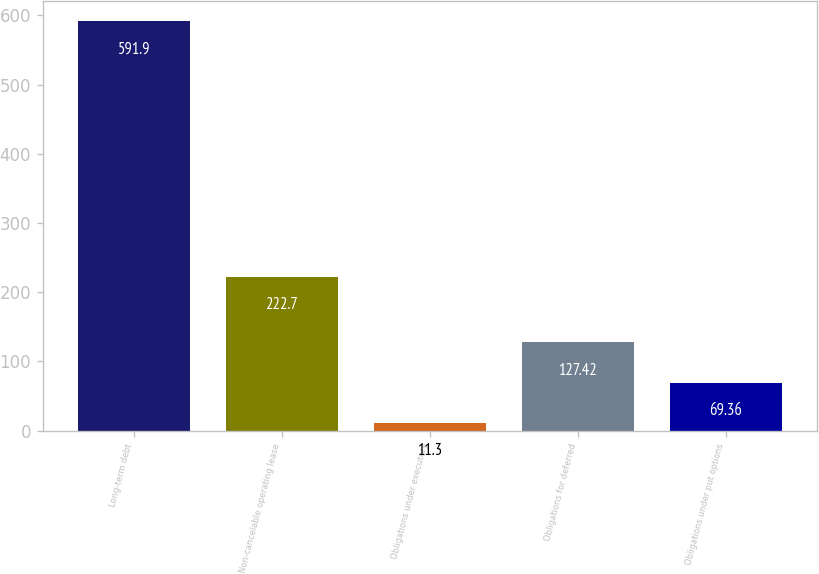<chart> <loc_0><loc_0><loc_500><loc_500><bar_chart><fcel>Long-term debt<fcel>Non-cancelable operating lease<fcel>Obligations under executory<fcel>Obligations for deferred<fcel>Obligations under put options<nl><fcel>591.9<fcel>222.7<fcel>11.3<fcel>127.42<fcel>69.36<nl></chart> 